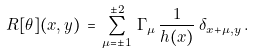<formula> <loc_0><loc_0><loc_500><loc_500>R [ \theta ] ( x , y ) \, = \, \sum _ { \mu = \pm 1 } ^ { \pm 2 } \, \Gamma _ { \mu } \, \frac { 1 } { h ( x ) } \, \delta _ { x + \mu , y } \, .</formula> 